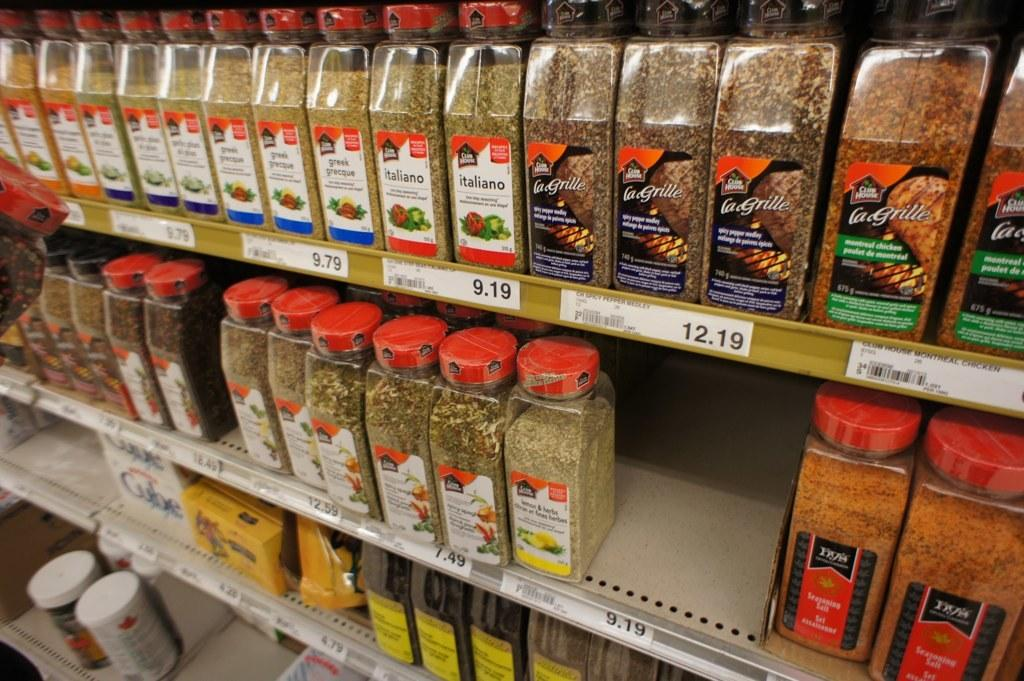What type of containers can be seen in the image? There are jars in the image. What else can be seen on the racks in the image? There are items in bottles on the racks. How can the cost of the items be determined in the image? Price tags are visible in the image. Can you tell me how many geese are on the skate in the image? There are no geese or skates present in the image. What is the result of adding the price of all the items in the image? We cannot determine the result of adding the price of all the items in the image, as we do not have the prices of each item. 